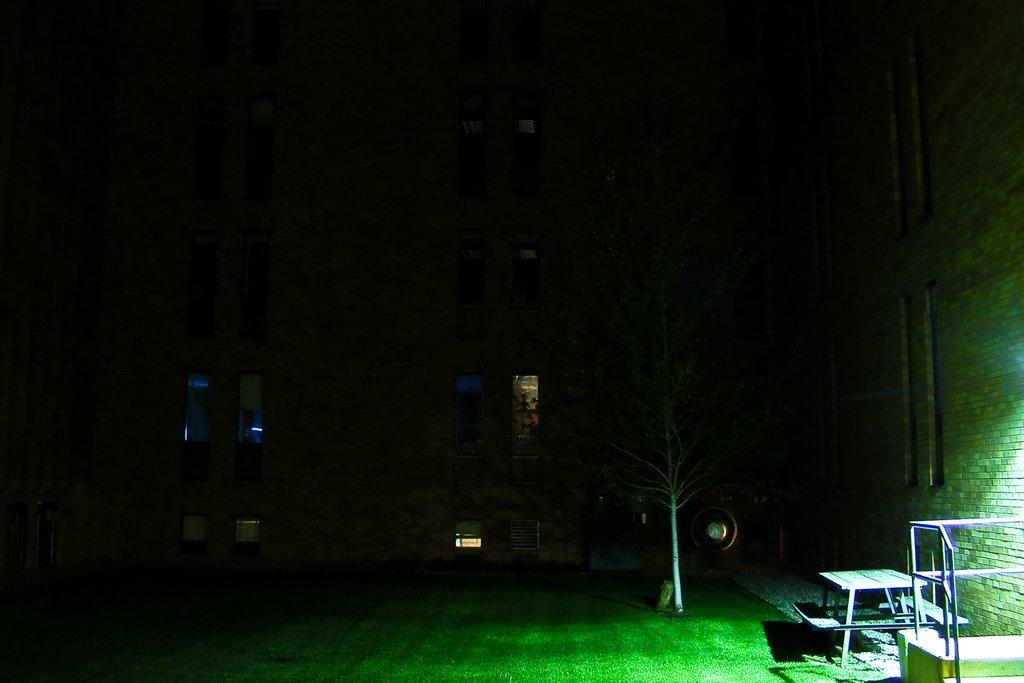What type of seating is visible in the image? There is a bench in the image. What type of barrier is present in the image? There is a fence in the image. What type of plant is visible in the image? There is a tree in the image. What type of openings are present in the image? There are windows in the image. What type of ground covering is visible in the image? There is grass in the image. What type of structure is present in the image? There is a wall in the image. How many squares can be seen in the image? There are no squares present in the image. Is there a beggar visible in the image? There is no beggar present in the image. 